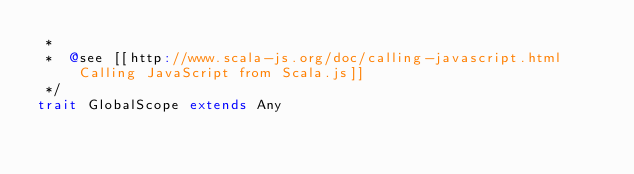Convert code to text. <code><loc_0><loc_0><loc_500><loc_500><_Scala_> *
 *  @see [[http://www.scala-js.org/doc/calling-javascript.html Calling JavaScript from Scala.js]]
 */
trait GlobalScope extends Any
</code> 